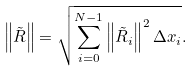<formula> <loc_0><loc_0><loc_500><loc_500>\left \| \tilde { R } \right \| = \sqrt { \sum _ { i = 0 } ^ { N - 1 } \left \| \tilde { R } _ { i } \right \| ^ { 2 } \Delta x _ { i } } .</formula> 